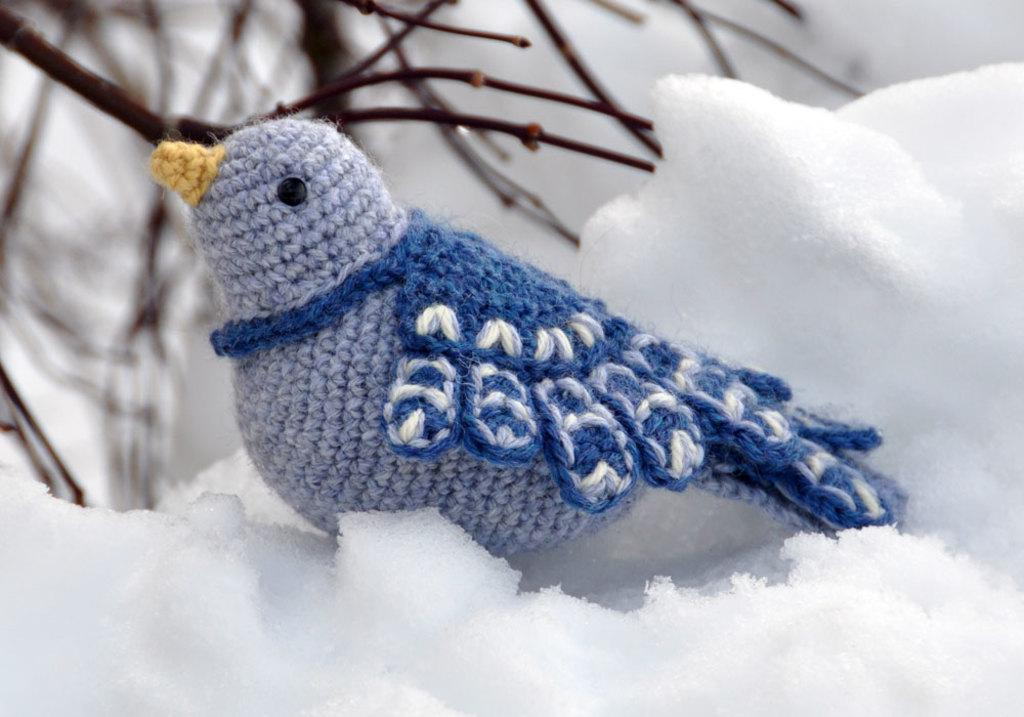What type of toy is present in the image? There is a toy bird in the image. Where is the toy bird located? The toy bird is on the snow. What else can be seen in the image besides the toy bird? There are twigs of a plant visible in the image. What type of underwear is the tiger wearing in the image? There is no tiger or underwear present in the image; it features a toy bird on the snow and twigs of a plant. 